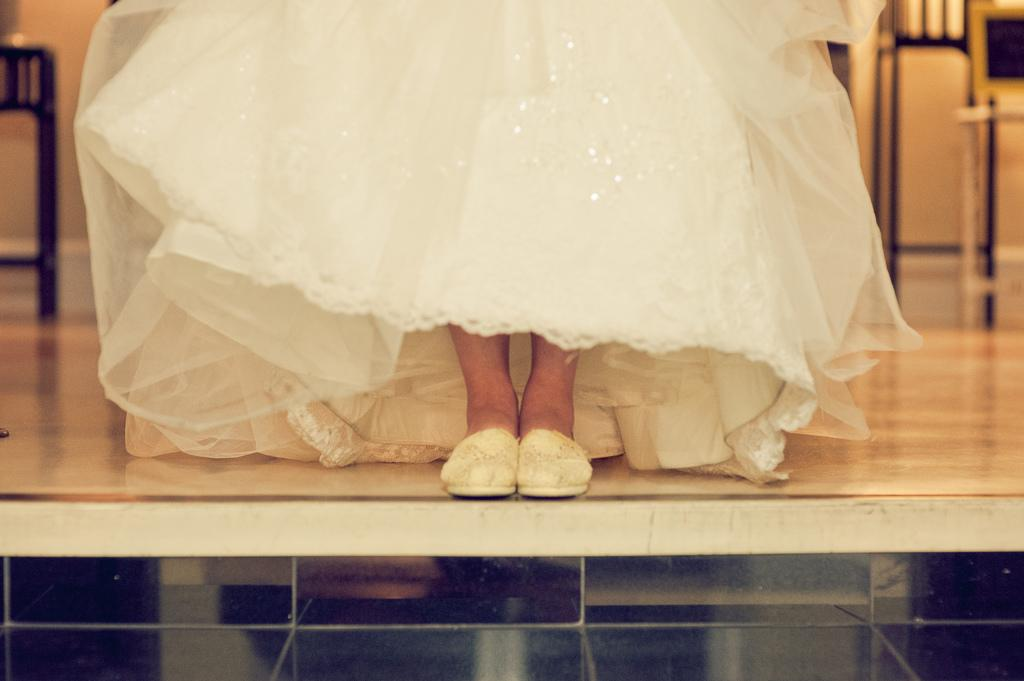Who or what is present in the image? There is a person in the image. What is the person doing in the image? The person is standing. What is the person wearing in the image? The person is wearing a white gown and white shoes. What type of pest can be seen crawling on the person's gown in the image? There are no pests visible in the image; the person is wearing a white gown and white shoes. 